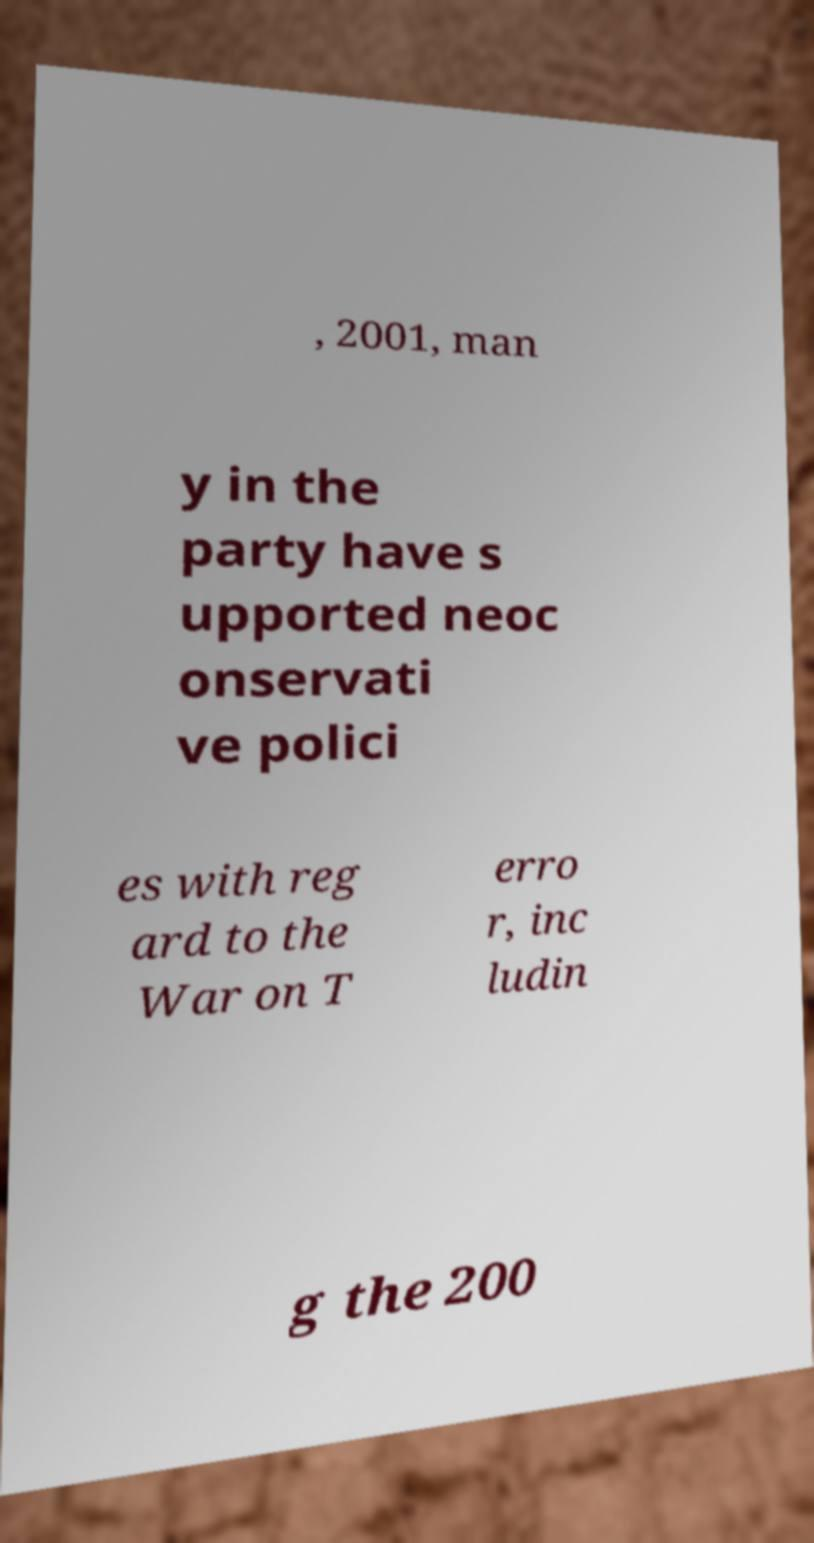Could you extract and type out the text from this image? , 2001, man y in the party have s upported neoc onservati ve polici es with reg ard to the War on T erro r, inc ludin g the 200 